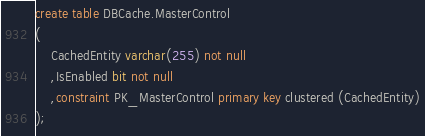<code> <loc_0><loc_0><loc_500><loc_500><_SQL_>create table DBCache.MasterControl
(
	CachedEntity varchar(255) not null
	,IsEnabled bit not null
	,constraint PK_MasterControl primary key clustered (CachedEntity)
);</code> 